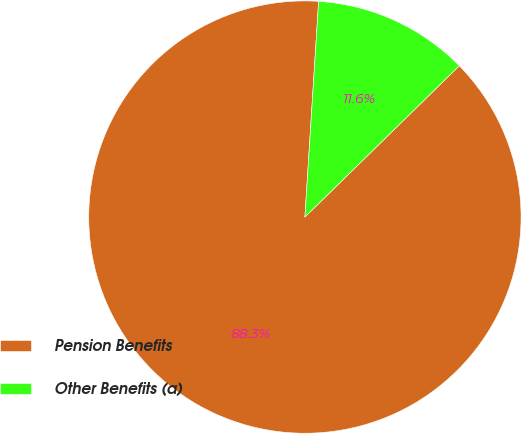Convert chart. <chart><loc_0><loc_0><loc_500><loc_500><pie_chart><fcel>Pension Benefits<fcel>Other Benefits (a)<nl><fcel>88.35%<fcel>11.65%<nl></chart> 